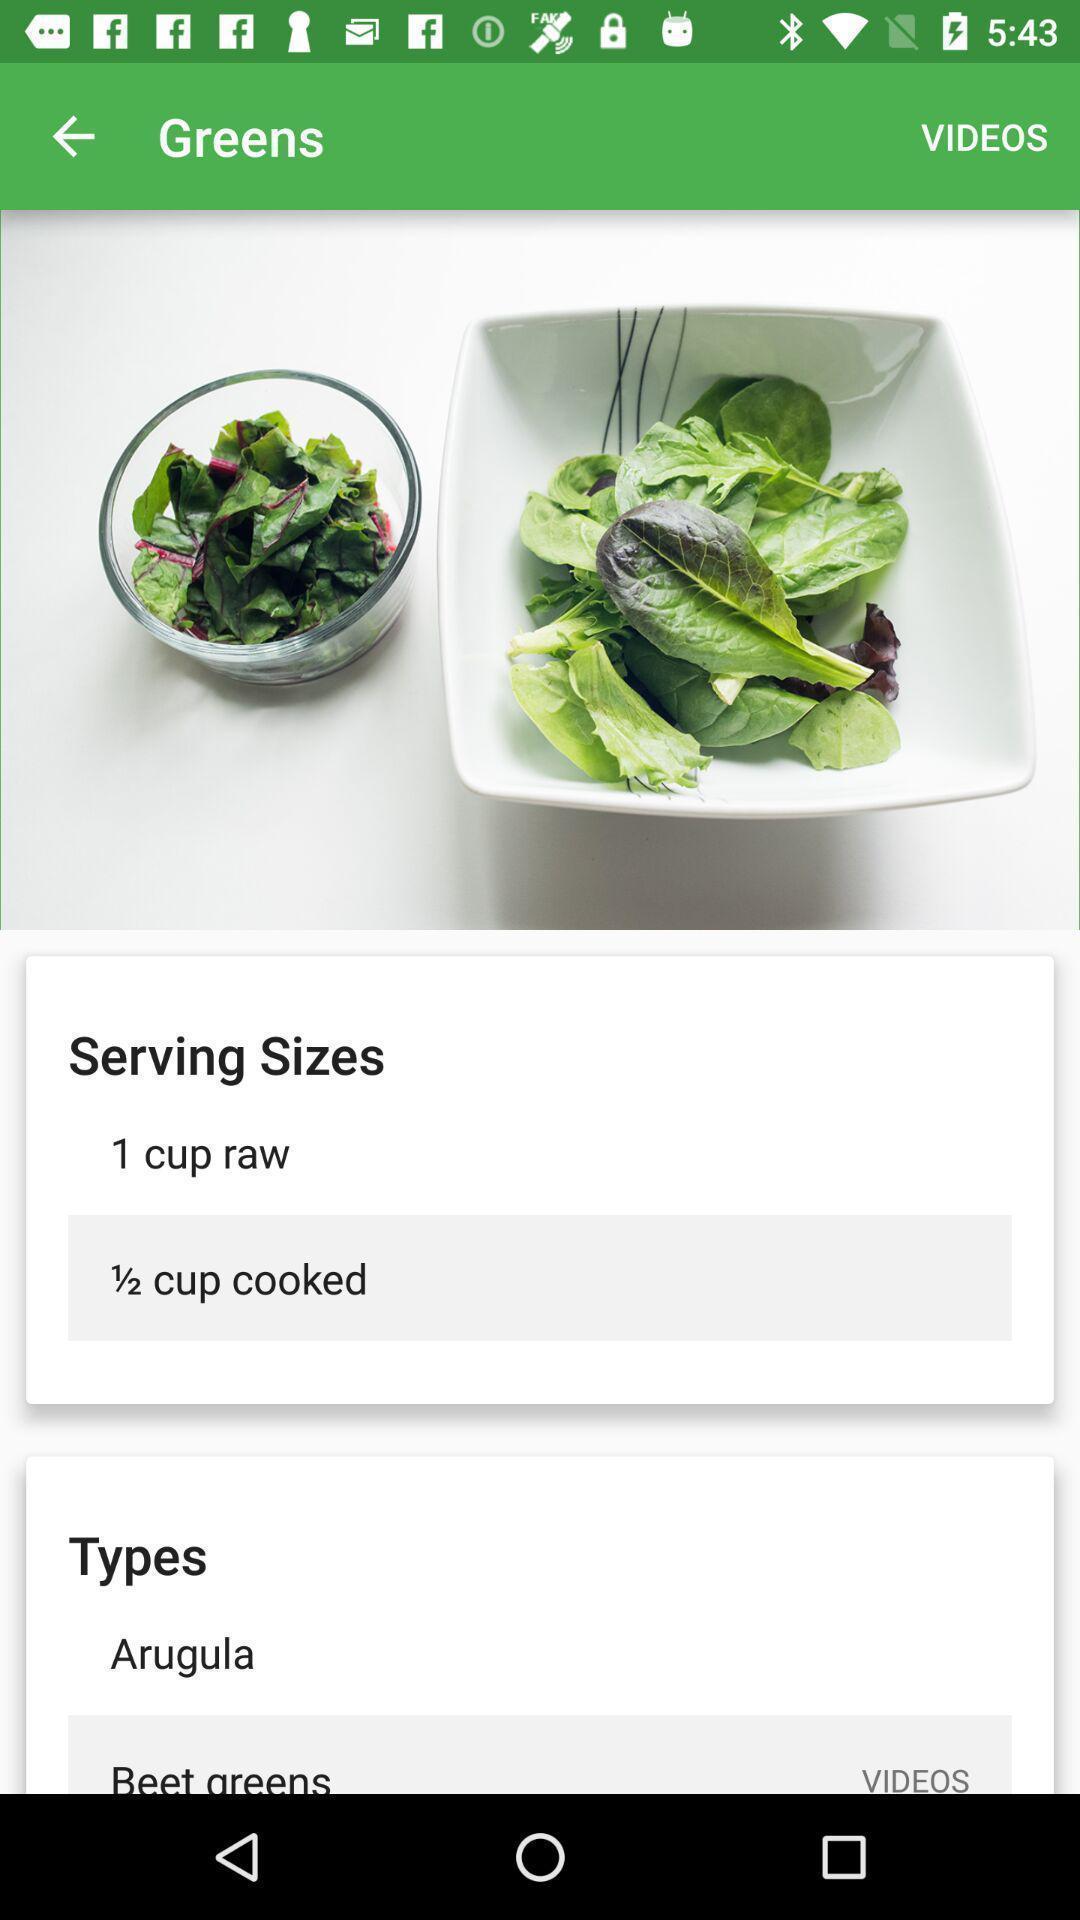Tell me what you see in this picture. Page showing multiple options on app. 